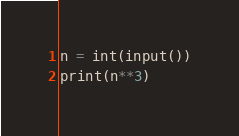<code> <loc_0><loc_0><loc_500><loc_500><_Python_>n = int(input())
print(n**3)</code> 